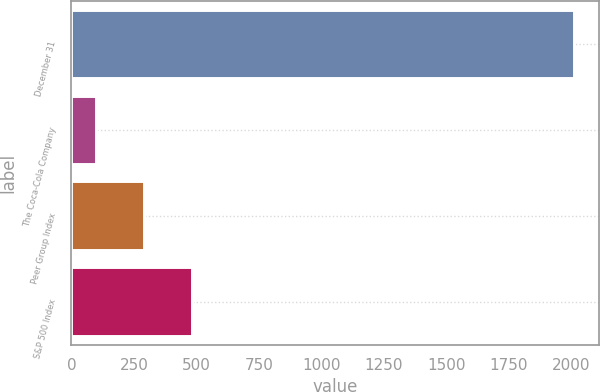Convert chart to OTSL. <chart><loc_0><loc_0><loc_500><loc_500><bar_chart><fcel>December 31<fcel>The Coca-Cola Company<fcel>Peer Group Index<fcel>S&P 500 Index<nl><fcel>2010<fcel>100<fcel>291<fcel>482<nl></chart> 